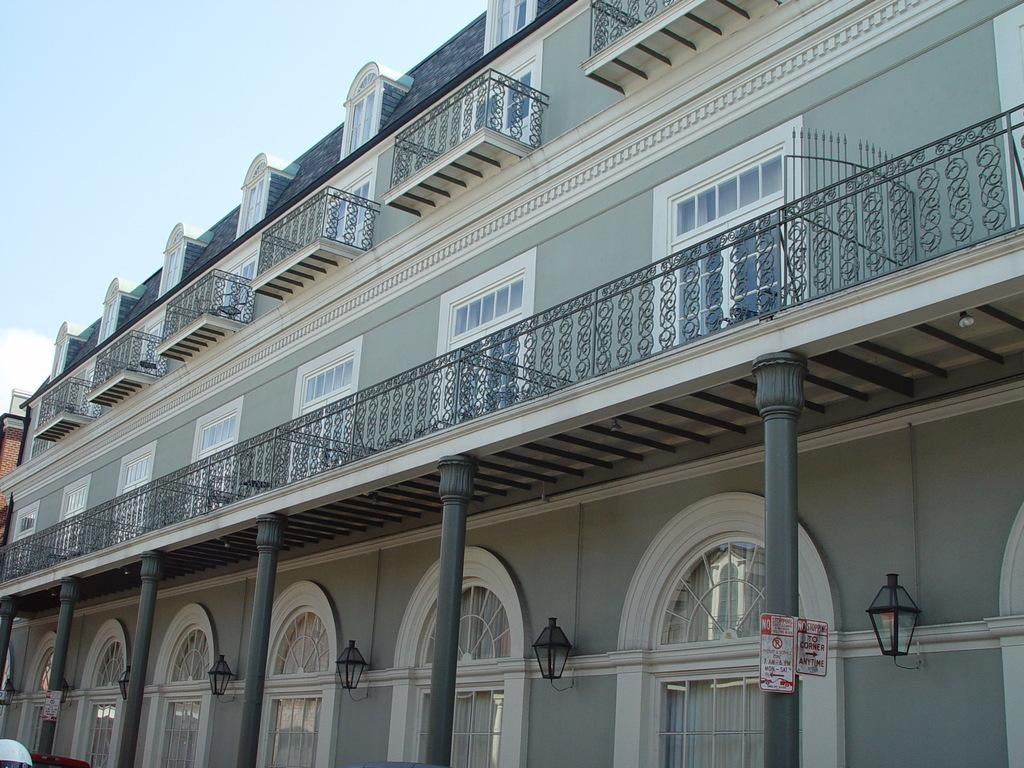What is the main subject in the foreground of the image? There is a building in the foreground of the image. What features can be observed on the building? The building has windows, a railing, and lamps. What is visible at the top of the image? The sky is visible at the top of the image. What type of soup is being served in the building in the image? There is no soup visible in the image, as it focuses on the building's exterior features. How many turkeys can be seen on the roof of the building in the image? There are no turkeys present on the roof or anywhere else in the image. 